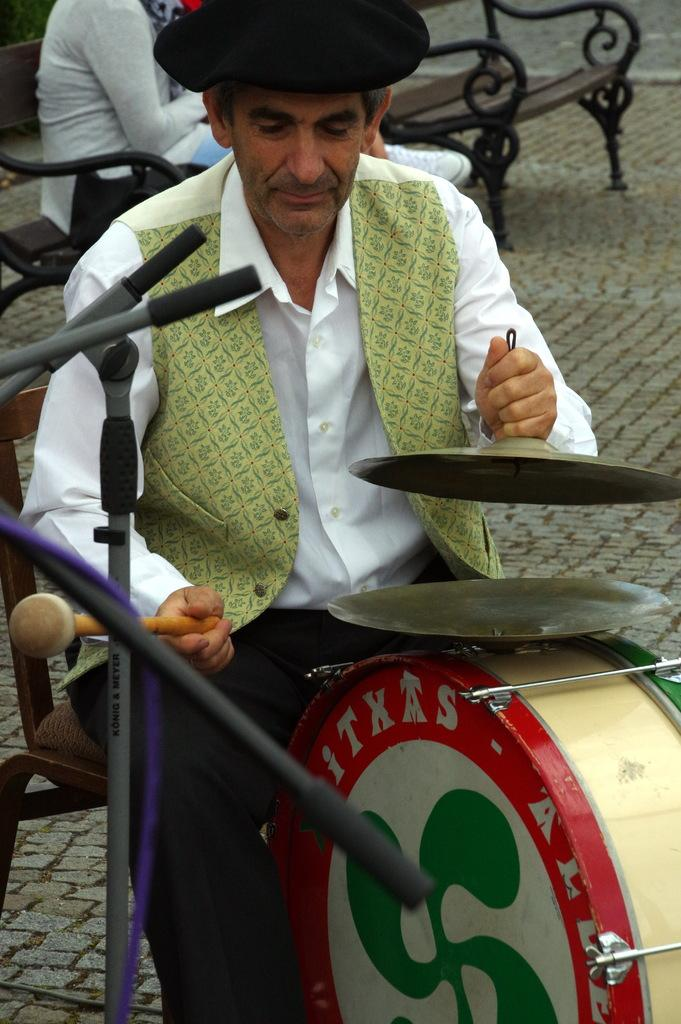What is the man in the image doing? The man is sitting on a chair and playing a musical instrument. Can you describe the position of the other person in the image? There is another person sitting on a chair in the image. What type of activity is taking place in the image? The activity in the image involves playing a musical instrument. What type of mitten is the man wearing while playing the musical instrument? There is no mention of a mitten in the image, and the man is not wearing any gloves or mittens. 